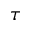<formula> <loc_0><loc_0><loc_500><loc_500>\tau</formula> 